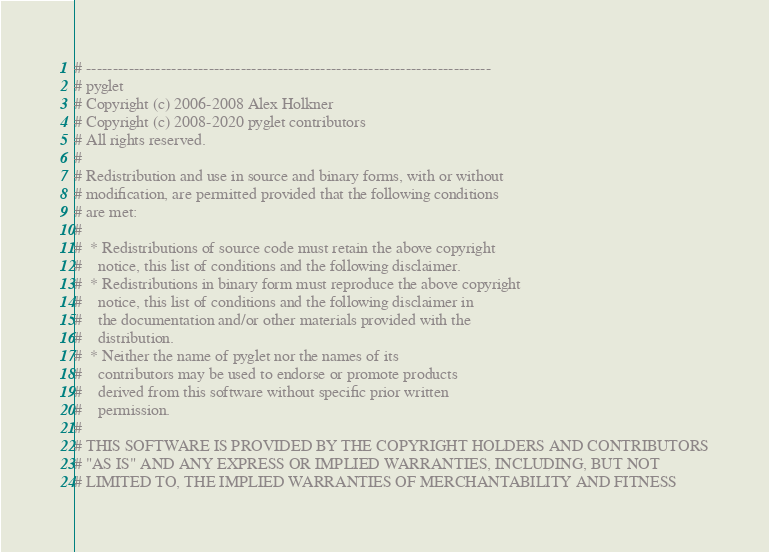Convert code to text. <code><loc_0><loc_0><loc_500><loc_500><_Python_># ----------------------------------------------------------------------------
# pyglet
# Copyright (c) 2006-2008 Alex Holkner
# Copyright (c) 2008-2020 pyglet contributors
# All rights reserved.
#
# Redistribution and use in source and binary forms, with or without
# modification, are permitted provided that the following conditions
# are met:
#
#  * Redistributions of source code must retain the above copyright
#    notice, this list of conditions and the following disclaimer.
#  * Redistributions in binary form must reproduce the above copyright
#    notice, this list of conditions and the following disclaimer in
#    the documentation and/or other materials provided with the
#    distribution.
#  * Neither the name of pyglet nor the names of its
#    contributors may be used to endorse or promote products
#    derived from this software without specific prior written
#    permission.
#
# THIS SOFTWARE IS PROVIDED BY THE COPYRIGHT HOLDERS AND CONTRIBUTORS
# "AS IS" AND ANY EXPRESS OR IMPLIED WARRANTIES, INCLUDING, BUT NOT
# LIMITED TO, THE IMPLIED WARRANTIES OF MERCHANTABILITY AND FITNESS</code> 